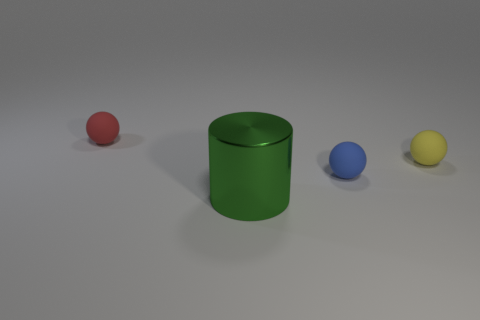Subtract all tiny blue balls. How many balls are left? 2 Add 1 blue rubber objects. How many objects exist? 5 Subtract all cylinders. How many objects are left? 3 Subtract all gray spheres. Subtract all yellow cubes. How many spheres are left? 3 Subtract all cyan cylinders. How many blue balls are left? 1 Subtract all red rubber objects. Subtract all small yellow objects. How many objects are left? 2 Add 2 green things. How many green things are left? 3 Add 2 small cyan cylinders. How many small cyan cylinders exist? 2 Subtract 1 green cylinders. How many objects are left? 3 